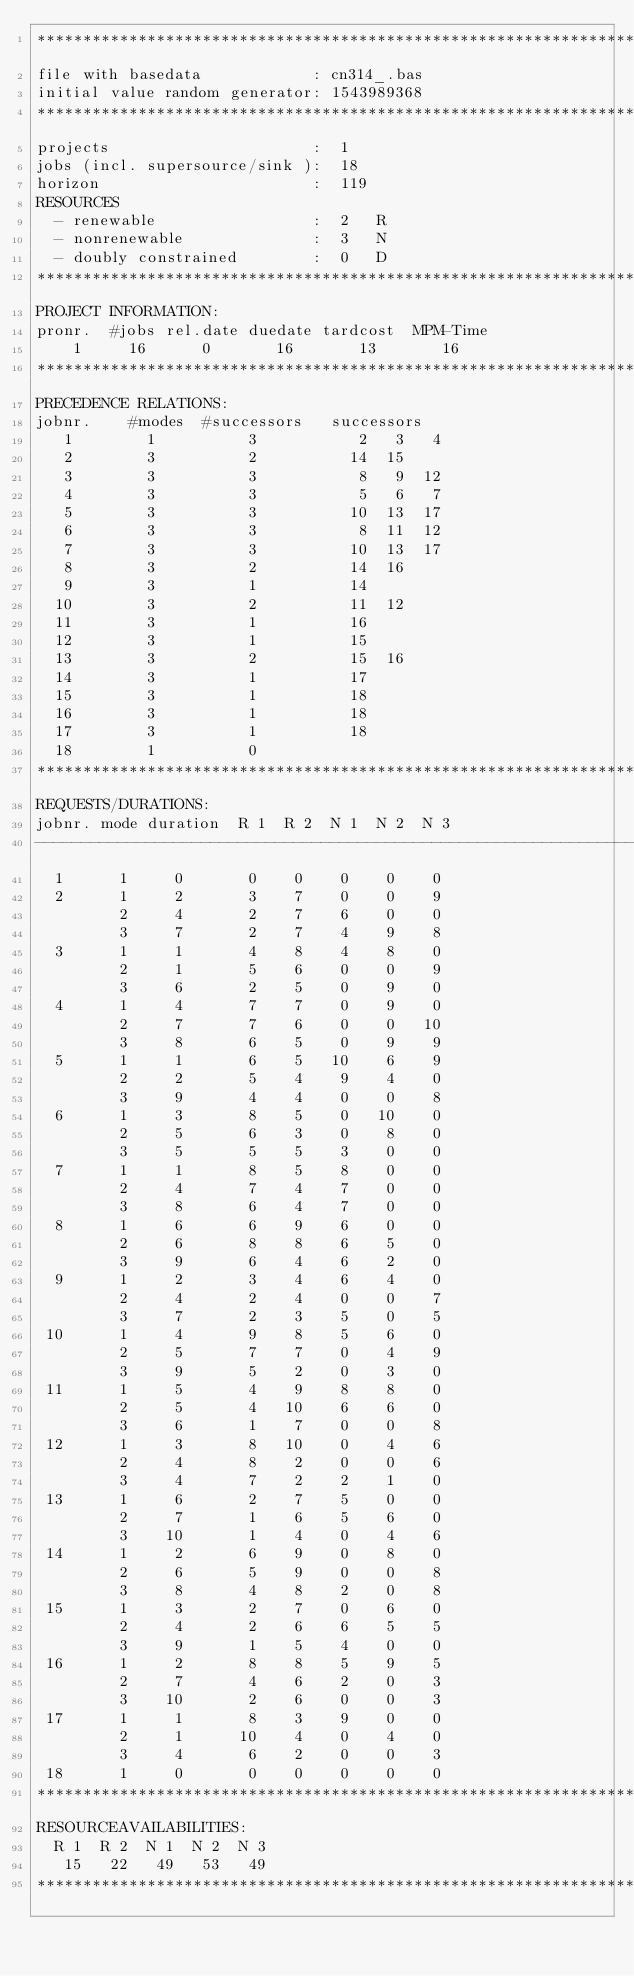<code> <loc_0><loc_0><loc_500><loc_500><_ObjectiveC_>************************************************************************
file with basedata            : cn314_.bas
initial value random generator: 1543989368
************************************************************************
projects                      :  1
jobs (incl. supersource/sink ):  18
horizon                       :  119
RESOURCES
  - renewable                 :  2   R
  - nonrenewable              :  3   N
  - doubly constrained        :  0   D
************************************************************************
PROJECT INFORMATION:
pronr.  #jobs rel.date duedate tardcost  MPM-Time
    1     16      0       16       13       16
************************************************************************
PRECEDENCE RELATIONS:
jobnr.    #modes  #successors   successors
   1        1          3           2   3   4
   2        3          2          14  15
   3        3          3           8   9  12
   4        3          3           5   6   7
   5        3          3          10  13  17
   6        3          3           8  11  12
   7        3          3          10  13  17
   8        3          2          14  16
   9        3          1          14
  10        3          2          11  12
  11        3          1          16
  12        3          1          15
  13        3          2          15  16
  14        3          1          17
  15        3          1          18
  16        3          1          18
  17        3          1          18
  18        1          0        
************************************************************************
REQUESTS/DURATIONS:
jobnr. mode duration  R 1  R 2  N 1  N 2  N 3
------------------------------------------------------------------------
  1      1     0       0    0    0    0    0
  2      1     2       3    7    0    0    9
         2     4       2    7    6    0    0
         3     7       2    7    4    9    8
  3      1     1       4    8    4    8    0
         2     1       5    6    0    0    9
         3     6       2    5    0    9    0
  4      1     4       7    7    0    9    0
         2     7       7    6    0    0   10
         3     8       6    5    0    9    9
  5      1     1       6    5   10    6    9
         2     2       5    4    9    4    0
         3     9       4    4    0    0    8
  6      1     3       8    5    0   10    0
         2     5       6    3    0    8    0
         3     5       5    5    3    0    0
  7      1     1       8    5    8    0    0
         2     4       7    4    7    0    0
         3     8       6    4    7    0    0
  8      1     6       6    9    6    0    0
         2     6       8    8    6    5    0
         3     9       6    4    6    2    0
  9      1     2       3    4    6    4    0
         2     4       2    4    0    0    7
         3     7       2    3    5    0    5
 10      1     4       9    8    5    6    0
         2     5       7    7    0    4    9
         3     9       5    2    0    3    0
 11      1     5       4    9    8    8    0
         2     5       4   10    6    6    0
         3     6       1    7    0    0    8
 12      1     3       8   10    0    4    6
         2     4       8    2    0    0    6
         3     4       7    2    2    1    0
 13      1     6       2    7    5    0    0
         2     7       1    6    5    6    0
         3    10       1    4    0    4    6
 14      1     2       6    9    0    8    0
         2     6       5    9    0    0    8
         3     8       4    8    2    0    8
 15      1     3       2    7    0    6    0
         2     4       2    6    6    5    5
         3     9       1    5    4    0    0
 16      1     2       8    8    5    9    5
         2     7       4    6    2    0    3
         3    10       2    6    0    0    3
 17      1     1       8    3    9    0    0
         2     1      10    4    0    4    0
         3     4       6    2    0    0    3
 18      1     0       0    0    0    0    0
************************************************************************
RESOURCEAVAILABILITIES:
  R 1  R 2  N 1  N 2  N 3
   15   22   49   53   49
************************************************************************
</code> 